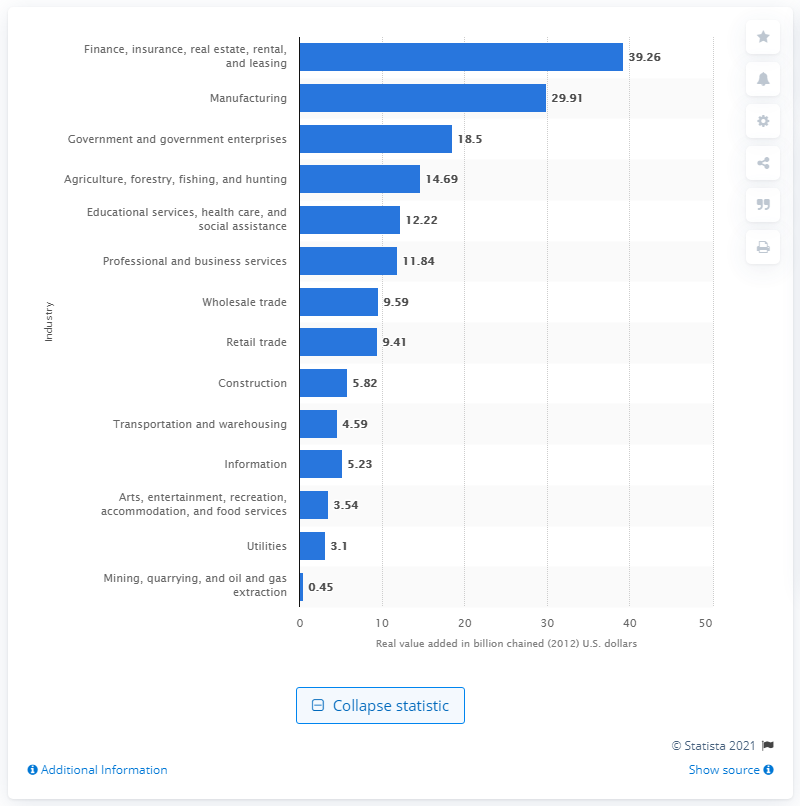Point out several critical features in this image. In 2020, the finance, insurance, real estate, rental, and leasing industry contributed a total of 39.26% to Iowa's Gross Domestic Product (GDP). 